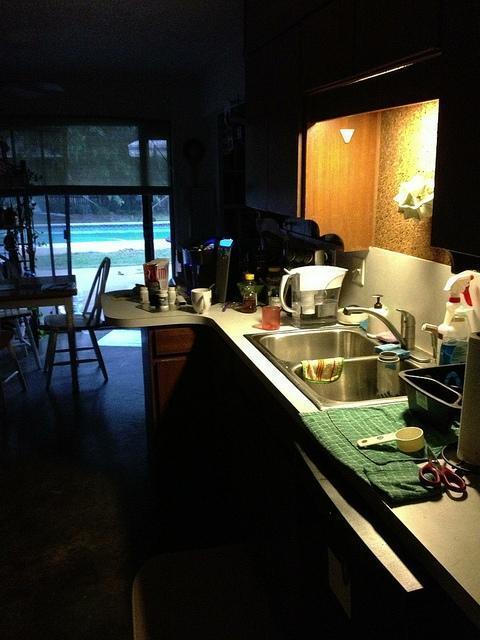What is to the right of the sink?
Select the accurate answer and provide explanation: 'Answer: answer
Rationale: rationale.'
Options: Cat, cardboard box, scissors, roach. Answer: scissors.
Rationale: There are no animals or boxes to the right of the sink. 